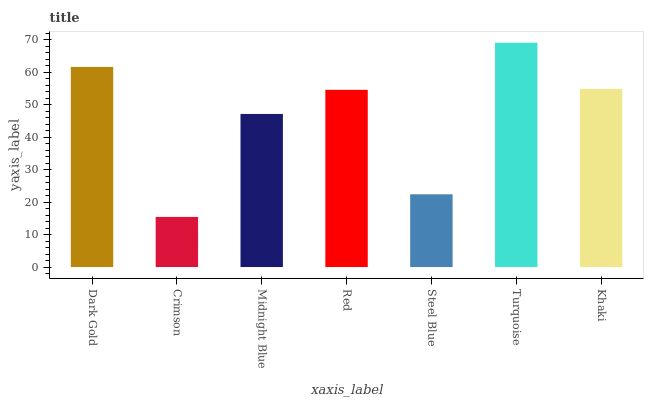Is Crimson the minimum?
Answer yes or no. Yes. Is Turquoise the maximum?
Answer yes or no. Yes. Is Midnight Blue the minimum?
Answer yes or no. No. Is Midnight Blue the maximum?
Answer yes or no. No. Is Midnight Blue greater than Crimson?
Answer yes or no. Yes. Is Crimson less than Midnight Blue?
Answer yes or no. Yes. Is Crimson greater than Midnight Blue?
Answer yes or no. No. Is Midnight Blue less than Crimson?
Answer yes or no. No. Is Red the high median?
Answer yes or no. Yes. Is Red the low median?
Answer yes or no. Yes. Is Crimson the high median?
Answer yes or no. No. Is Turquoise the low median?
Answer yes or no. No. 